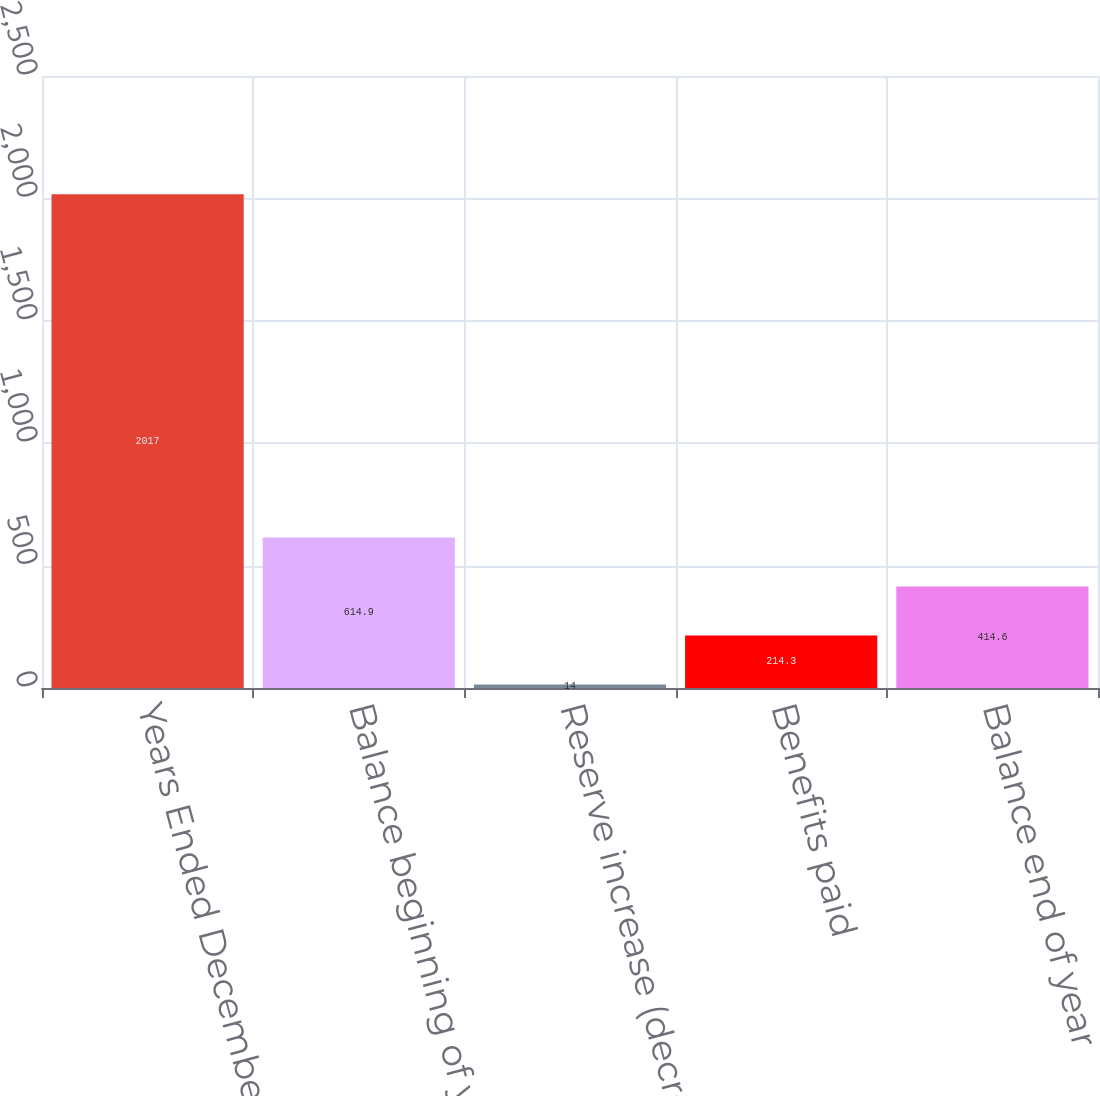Convert chart to OTSL. <chart><loc_0><loc_0><loc_500><loc_500><bar_chart><fcel>Years Ended December 31 (in<fcel>Balance beginning of year<fcel>Reserve increase (decrease)<fcel>Benefits paid<fcel>Balance end of year<nl><fcel>2017<fcel>614.9<fcel>14<fcel>214.3<fcel>414.6<nl></chart> 